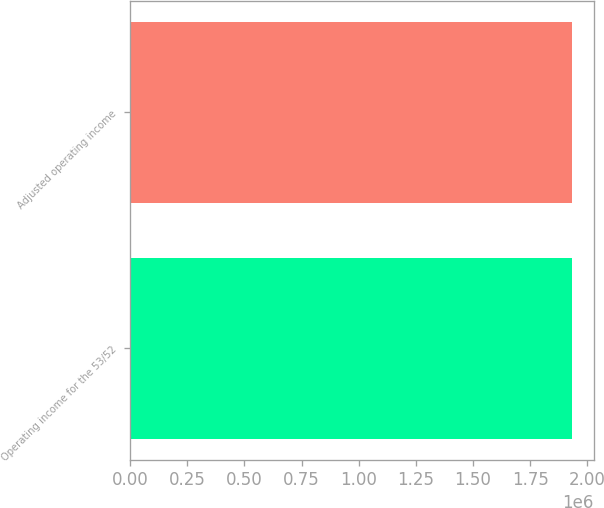Convert chart to OTSL. <chart><loc_0><loc_0><loc_500><loc_500><bar_chart><fcel>Operating income for the 53/52<fcel>Adjusted operating income<nl><fcel>1.9315e+06<fcel>1.9315e+06<nl></chart> 